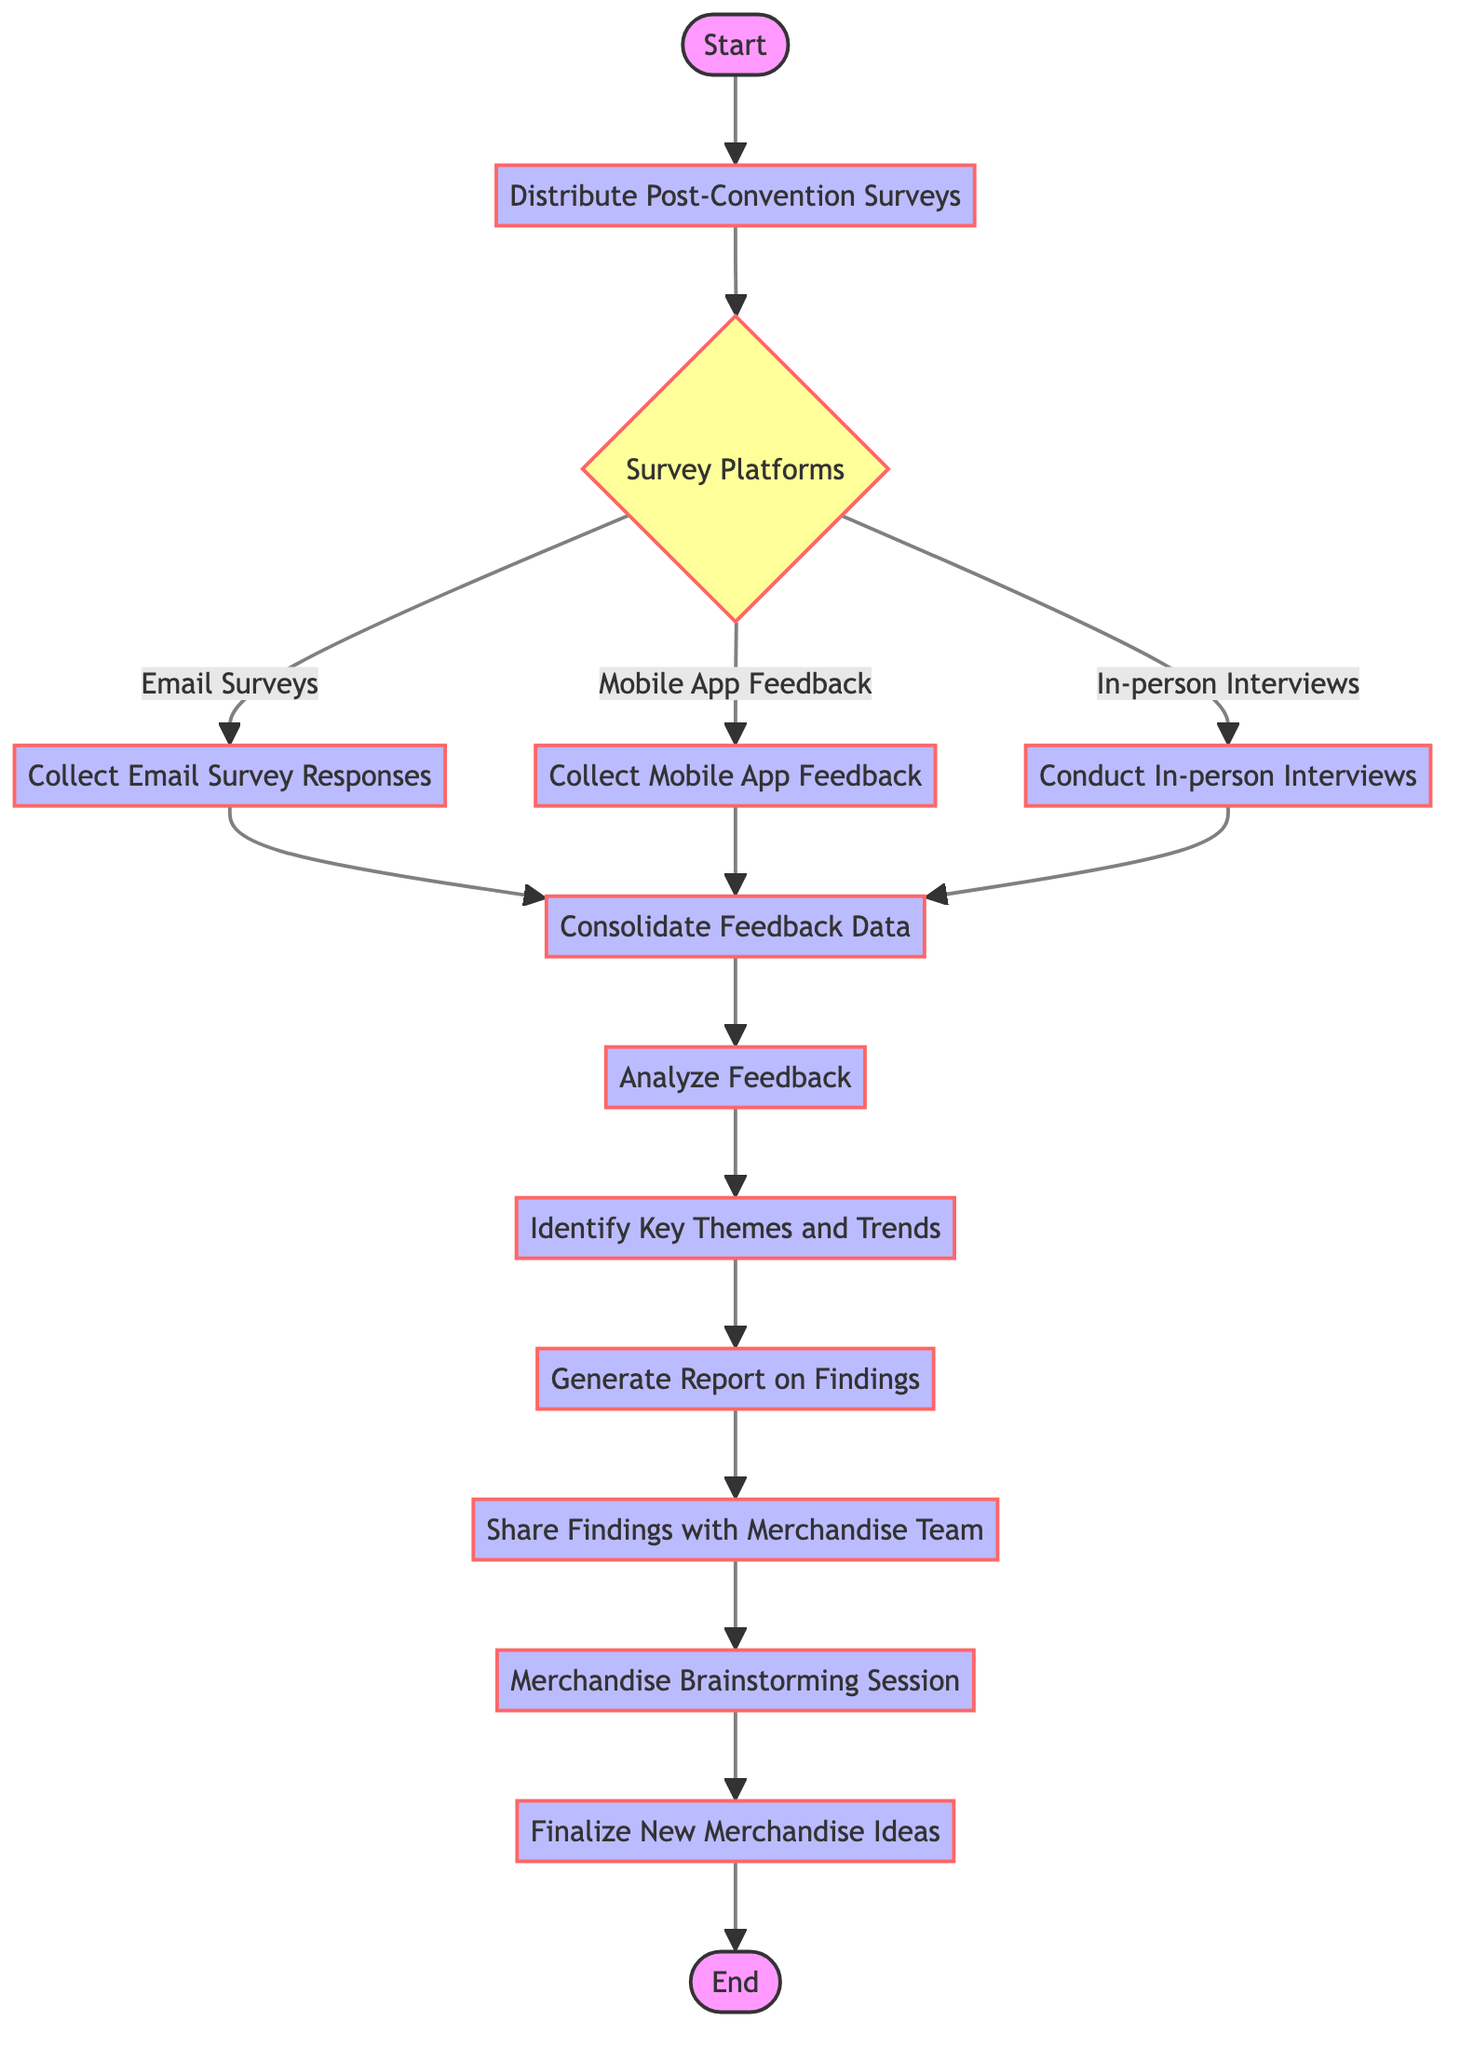What is the first step in the flow chart? The flow chart starts with the "Start" node, which indicates the beginning of the process.
Answer: Start How many decision points are in the diagram? There is one decision point labeled "Survey Platforms" that provides options for survey collection methods.
Answer: 1 What are the three options provided by the decision point? The three options at the "Survey Platforms" decision point are "Email Surveys," "Mobile App Feedback," and "In-person Interviews."
Answer: Email Surveys, Mobile App Feedback, In-person Interviews What is the last process step before reaching the end? The last process step before reaching the end is "Finalize New Merchandise Ideas," which concludes the feedback collection and analysis process.
Answer: Finalize New Merchandise Ideas What follows the "Analyze Feedback" step? After analyzing feedback, the next step is to "Identify Key Themes and Trends," guiding the decision-making for new merchandise ideas.
Answer: Identify Key Themes and Trends How do you consolidate feedback data? Feedback data is consolidated after collecting responses from the chosen survey methods, indicating that all collected data is combined before analysis.
Answer: Consolidate Feedback Data If selecting "Mobile App Feedback," what will the next process step be? If "Mobile App Feedback" is selected, the next process step after that will be to "Collect Mobile App Feedback."
Answer: Collect Mobile App Feedback Which step shares findings with the merchandise team? The step labeled "Share Findings with Merchandise Team" indicates that the analyzed feedback is communicated to the team responsible for merchandise decisions.
Answer: Share Findings with Merchandise Team 